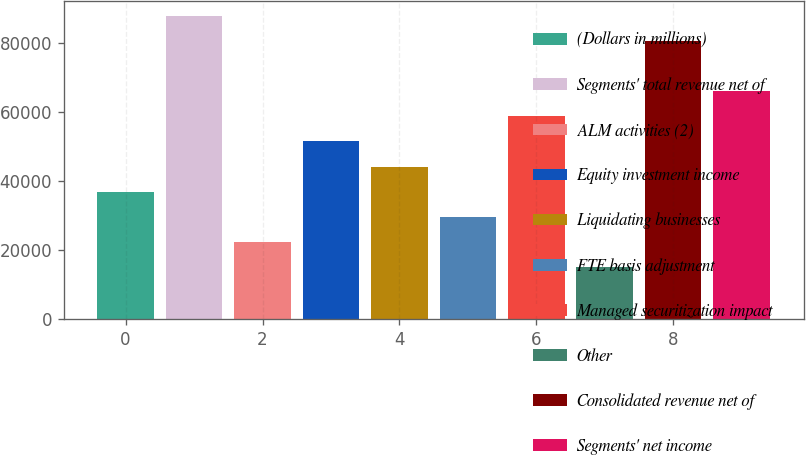Convert chart to OTSL. <chart><loc_0><loc_0><loc_500><loc_500><bar_chart><fcel>(Dollars in millions)<fcel>Segments' total revenue net of<fcel>ALM activities (2)<fcel>Equity investment income<fcel>Liquidating businesses<fcel>FTE basis adjustment<fcel>Managed securitization impact<fcel>Other<fcel>Consolidated revenue net of<fcel>Segments' net income<nl><fcel>36975.5<fcel>88031.4<fcel>22388.1<fcel>51562.9<fcel>44269.2<fcel>29681.8<fcel>58856.6<fcel>15094.4<fcel>80737.7<fcel>66150.3<nl></chart> 